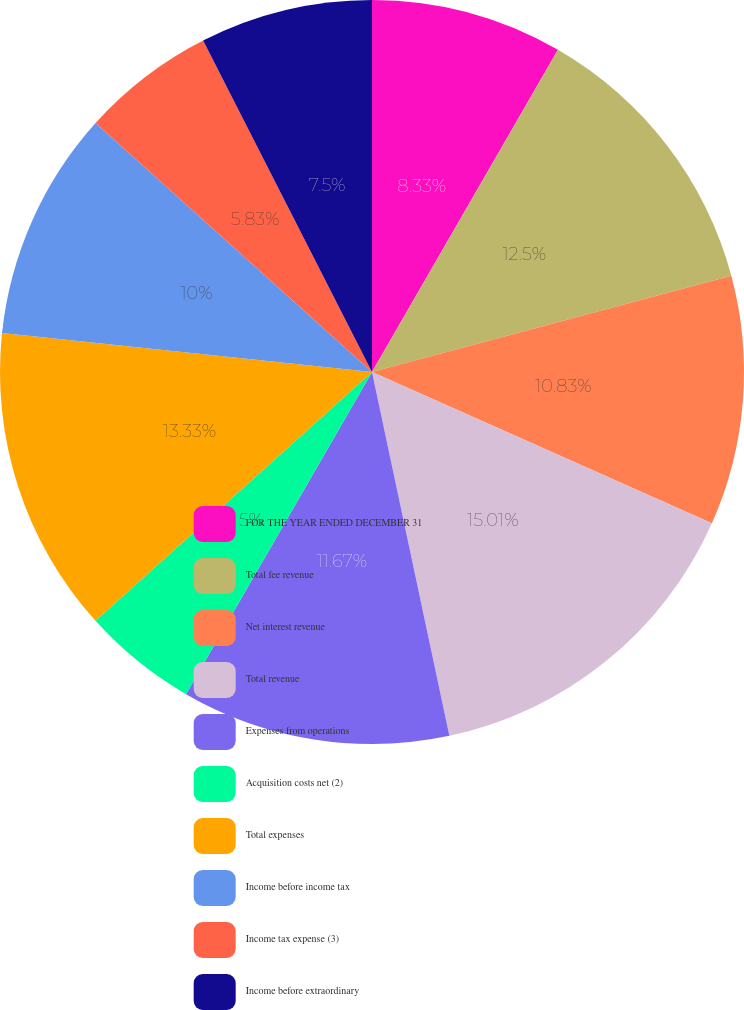Convert chart to OTSL. <chart><loc_0><loc_0><loc_500><loc_500><pie_chart><fcel>FOR THE YEAR ENDED DECEMBER 31<fcel>Total fee revenue<fcel>Net interest revenue<fcel>Total revenue<fcel>Expenses from operations<fcel>Acquisition costs net (2)<fcel>Total expenses<fcel>Income before income tax<fcel>Income tax expense (3)<fcel>Income before extraordinary<nl><fcel>8.33%<fcel>12.5%<fcel>10.83%<fcel>15.0%<fcel>11.67%<fcel>5.0%<fcel>13.33%<fcel>10.0%<fcel>5.83%<fcel>7.5%<nl></chart> 